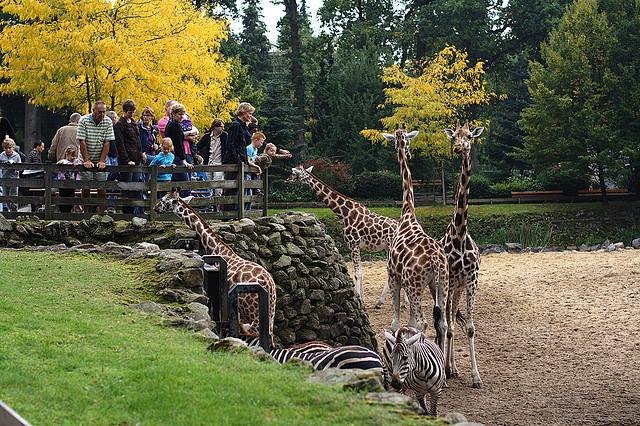Are there people in the picture?
Give a very brief answer. Yes. Are any of the animals laying down?
Concise answer only. No. Is this a park?
Short answer required. Yes. Are those animals carnivores?
Give a very brief answer. No. How many giraffes are standing?
Be succinct. 4. 